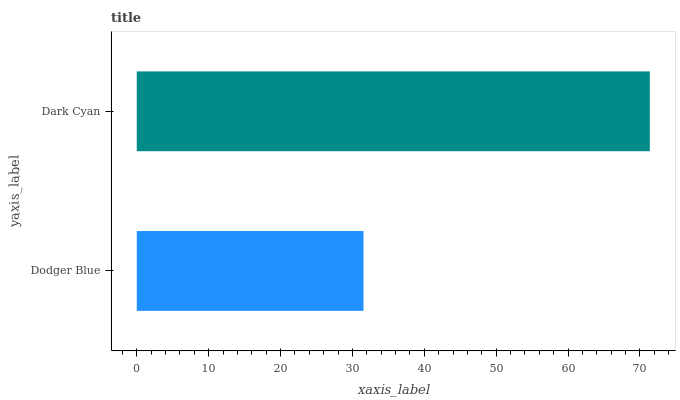Is Dodger Blue the minimum?
Answer yes or no. Yes. Is Dark Cyan the maximum?
Answer yes or no. Yes. Is Dark Cyan the minimum?
Answer yes or no. No. Is Dark Cyan greater than Dodger Blue?
Answer yes or no. Yes. Is Dodger Blue less than Dark Cyan?
Answer yes or no. Yes. Is Dodger Blue greater than Dark Cyan?
Answer yes or no. No. Is Dark Cyan less than Dodger Blue?
Answer yes or no. No. Is Dark Cyan the high median?
Answer yes or no. Yes. Is Dodger Blue the low median?
Answer yes or no. Yes. Is Dodger Blue the high median?
Answer yes or no. No. Is Dark Cyan the low median?
Answer yes or no. No. 